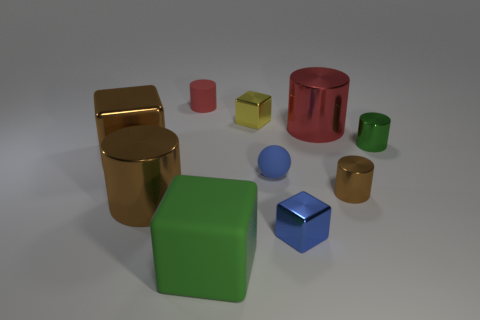Subtract all green cylinders. How many cylinders are left? 4 Subtract all brown cylinders. How many cylinders are left? 3 Subtract all cubes. How many objects are left? 6 Subtract all small purple things. Subtract all small yellow metal objects. How many objects are left? 9 Add 2 blue things. How many blue things are left? 4 Add 8 small blue metal blocks. How many small blue metal blocks exist? 9 Subtract 1 blue cubes. How many objects are left? 9 Subtract 1 blocks. How many blocks are left? 3 Subtract all red cubes. Subtract all red cylinders. How many cubes are left? 4 Subtract all blue cylinders. How many brown spheres are left? 0 